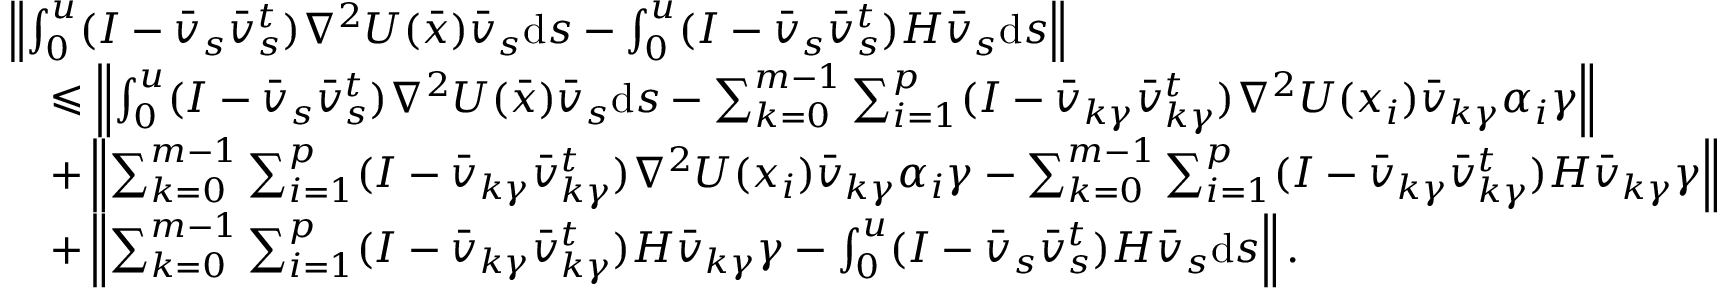<formula> <loc_0><loc_0><loc_500><loc_500>\begin{array} { r l } & { \left \| \int _ { 0 } ^ { u } ( I - \bar { v } _ { s } \bar { v } _ { s } ^ { t } ) \nabla ^ { 2 } U ( \bar { x } ) \bar { v } _ { s } d s - \int _ { 0 } ^ { u } ( I - \bar { v } _ { s } \bar { v } _ { s } ^ { t } ) H \bar { v } _ { s } d s \right \| } \\ & { \quad \leqslant \left \| \int _ { 0 } ^ { u } ( I - \bar { v } _ { s } \bar { v } _ { s } ^ { t } ) \nabla ^ { 2 } U ( \bar { x } ) \bar { v } _ { s } d s - \sum _ { k = 0 } ^ { m - 1 } \sum _ { i = 1 } ^ { p } ( I - \bar { v } _ { k \gamma } \bar { v } _ { k \gamma } ^ { t } ) \nabla ^ { 2 } U ( x _ { i } ) \bar { v } _ { k \gamma } \alpha _ { i } \gamma \right \| } \\ & { \quad + \left \| \sum _ { k = 0 } ^ { m - 1 } \sum _ { i = 1 } ^ { p } ( I - \bar { v } _ { k \gamma } \bar { v } _ { k \gamma } ^ { t } ) \nabla ^ { 2 } U ( x _ { i } ) \bar { v } _ { k \gamma } \alpha _ { i } \gamma - \sum _ { k = 0 } ^ { m - 1 } \sum _ { i = 1 } ^ { p } ( I - \bar { v } _ { k \gamma } \bar { v } _ { k \gamma } ^ { t } ) H \bar { v } _ { k \gamma } \gamma \right \| } \\ & { \quad + \left \| \sum _ { k = 0 } ^ { m - 1 } \sum _ { i = 1 } ^ { p } ( I - \bar { v } _ { k \gamma } \bar { v } _ { k \gamma } ^ { t } ) H \bar { v } _ { k \gamma } \gamma - \int _ { 0 } ^ { u } ( I - \bar { v } _ { s } \bar { v } _ { s } ^ { t } ) H \bar { v } _ { s } d s \right \| . } \end{array}</formula> 